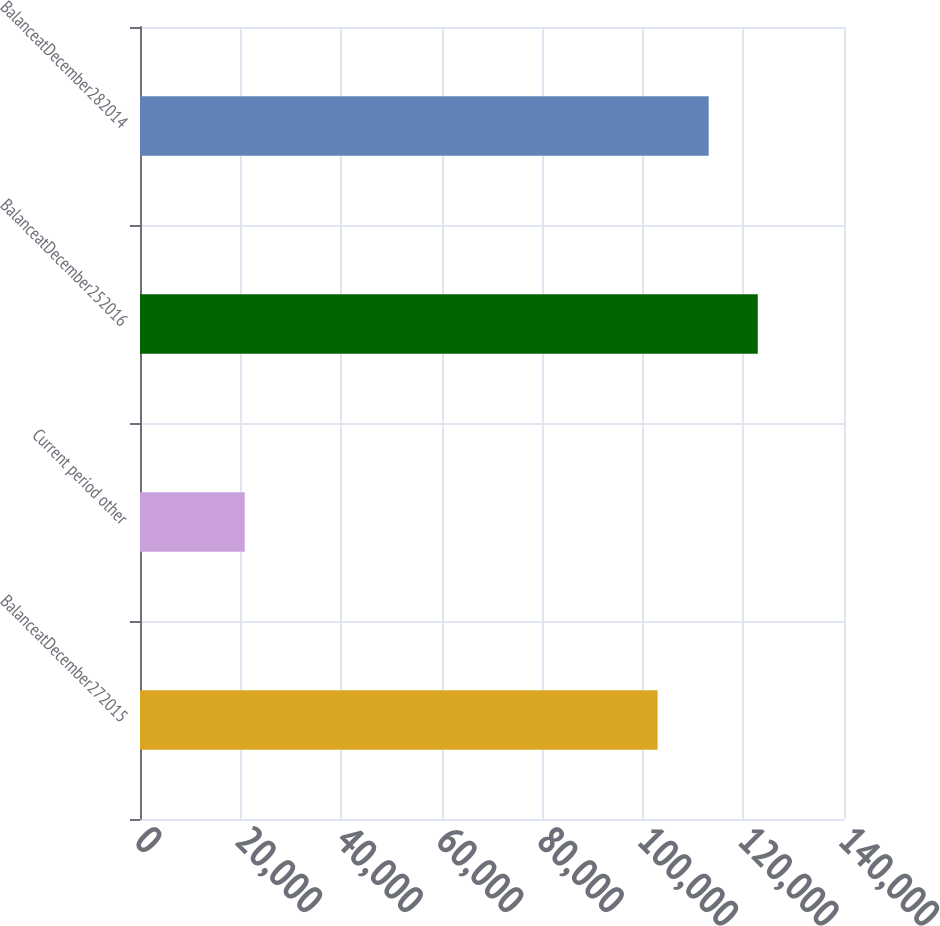<chart> <loc_0><loc_0><loc_500><loc_500><bar_chart><fcel>BalanceatDecember272015<fcel>Current period other<fcel>BalanceatDecember252016<fcel>BalanceatDecember282014<nl><fcel>102931<fcel>20829<fcel>122849<fcel>113092<nl></chart> 